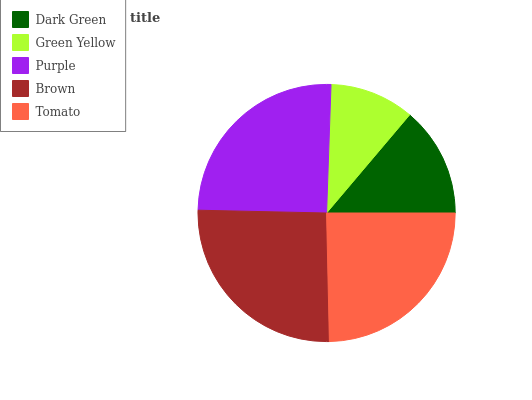Is Green Yellow the minimum?
Answer yes or no. Yes. Is Brown the maximum?
Answer yes or no. Yes. Is Purple the minimum?
Answer yes or no. No. Is Purple the maximum?
Answer yes or no. No. Is Purple greater than Green Yellow?
Answer yes or no. Yes. Is Green Yellow less than Purple?
Answer yes or no. Yes. Is Green Yellow greater than Purple?
Answer yes or no. No. Is Purple less than Green Yellow?
Answer yes or no. No. Is Tomato the high median?
Answer yes or no. Yes. Is Tomato the low median?
Answer yes or no. Yes. Is Green Yellow the high median?
Answer yes or no. No. Is Purple the low median?
Answer yes or no. No. 